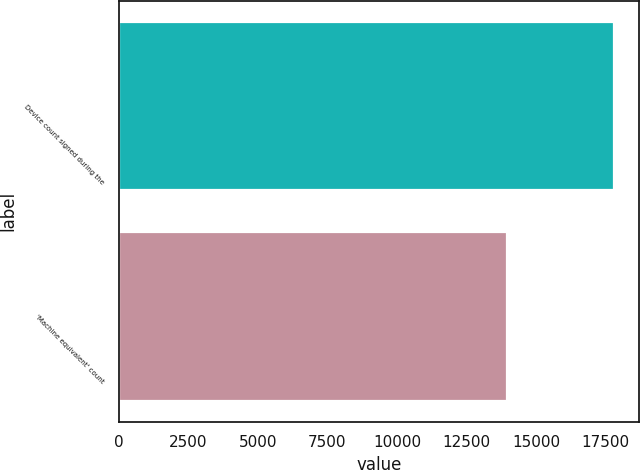Convert chart. <chart><loc_0><loc_0><loc_500><loc_500><bar_chart><fcel>Device count signed during the<fcel>'Machine equivalent' count<nl><fcel>17811<fcel>13935<nl></chart> 